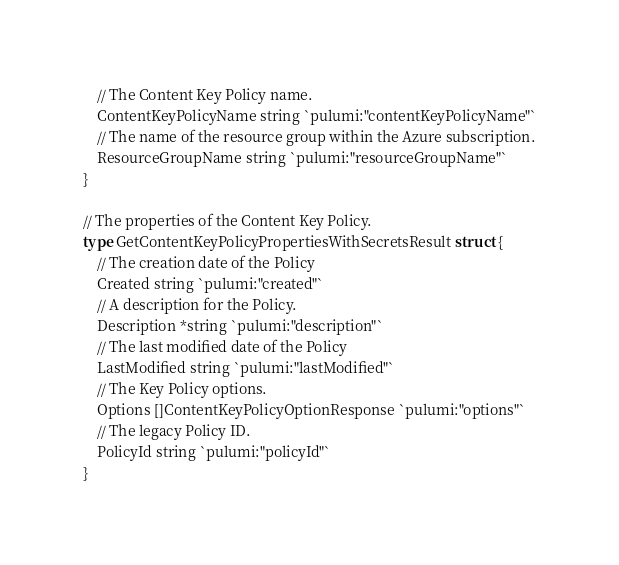<code> <loc_0><loc_0><loc_500><loc_500><_Go_>	// The Content Key Policy name.
	ContentKeyPolicyName string `pulumi:"contentKeyPolicyName"`
	// The name of the resource group within the Azure subscription.
	ResourceGroupName string `pulumi:"resourceGroupName"`
}

// The properties of the Content Key Policy.
type GetContentKeyPolicyPropertiesWithSecretsResult struct {
	// The creation date of the Policy
	Created string `pulumi:"created"`
	// A description for the Policy.
	Description *string `pulumi:"description"`
	// The last modified date of the Policy
	LastModified string `pulumi:"lastModified"`
	// The Key Policy options.
	Options []ContentKeyPolicyOptionResponse `pulumi:"options"`
	// The legacy Policy ID.
	PolicyId string `pulumi:"policyId"`
}
</code> 